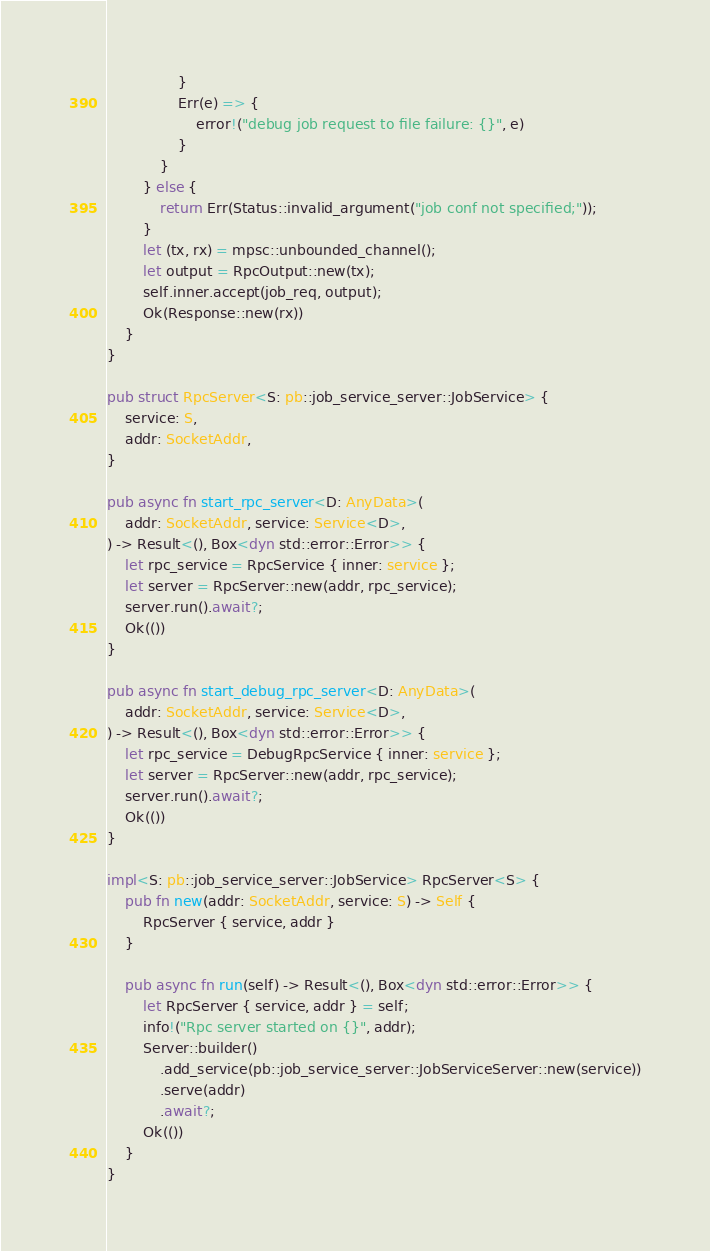Convert code to text. <code><loc_0><loc_0><loc_500><loc_500><_Rust_>                }
                Err(e) => {
                    error!("debug job request to file failure: {}", e)
                }
            }
        } else {
            return Err(Status::invalid_argument("job conf not specified;"));
        }
        let (tx, rx) = mpsc::unbounded_channel();
        let output = RpcOutput::new(tx);
        self.inner.accept(job_req, output);
        Ok(Response::new(rx))
    }
}

pub struct RpcServer<S: pb::job_service_server::JobService> {
    service: S,
    addr: SocketAddr,
}

pub async fn start_rpc_server<D: AnyData>(
    addr: SocketAddr, service: Service<D>,
) -> Result<(), Box<dyn std::error::Error>> {
    let rpc_service = RpcService { inner: service };
    let server = RpcServer::new(addr, rpc_service);
    server.run().await?;
    Ok(())
}

pub async fn start_debug_rpc_server<D: AnyData>(
    addr: SocketAddr, service: Service<D>,
) -> Result<(), Box<dyn std::error::Error>> {
    let rpc_service = DebugRpcService { inner: service };
    let server = RpcServer::new(addr, rpc_service);
    server.run().await?;
    Ok(())
}

impl<S: pb::job_service_server::JobService> RpcServer<S> {
    pub fn new(addr: SocketAddr, service: S) -> Self {
        RpcServer { service, addr }
    }

    pub async fn run(self) -> Result<(), Box<dyn std::error::Error>> {
        let RpcServer { service, addr } = self;
        info!("Rpc server started on {}", addr);
        Server::builder()
            .add_service(pb::job_service_server::JobServiceServer::new(service))
            .serve(addr)
            .await?;
        Ok(())
    }
}
</code> 